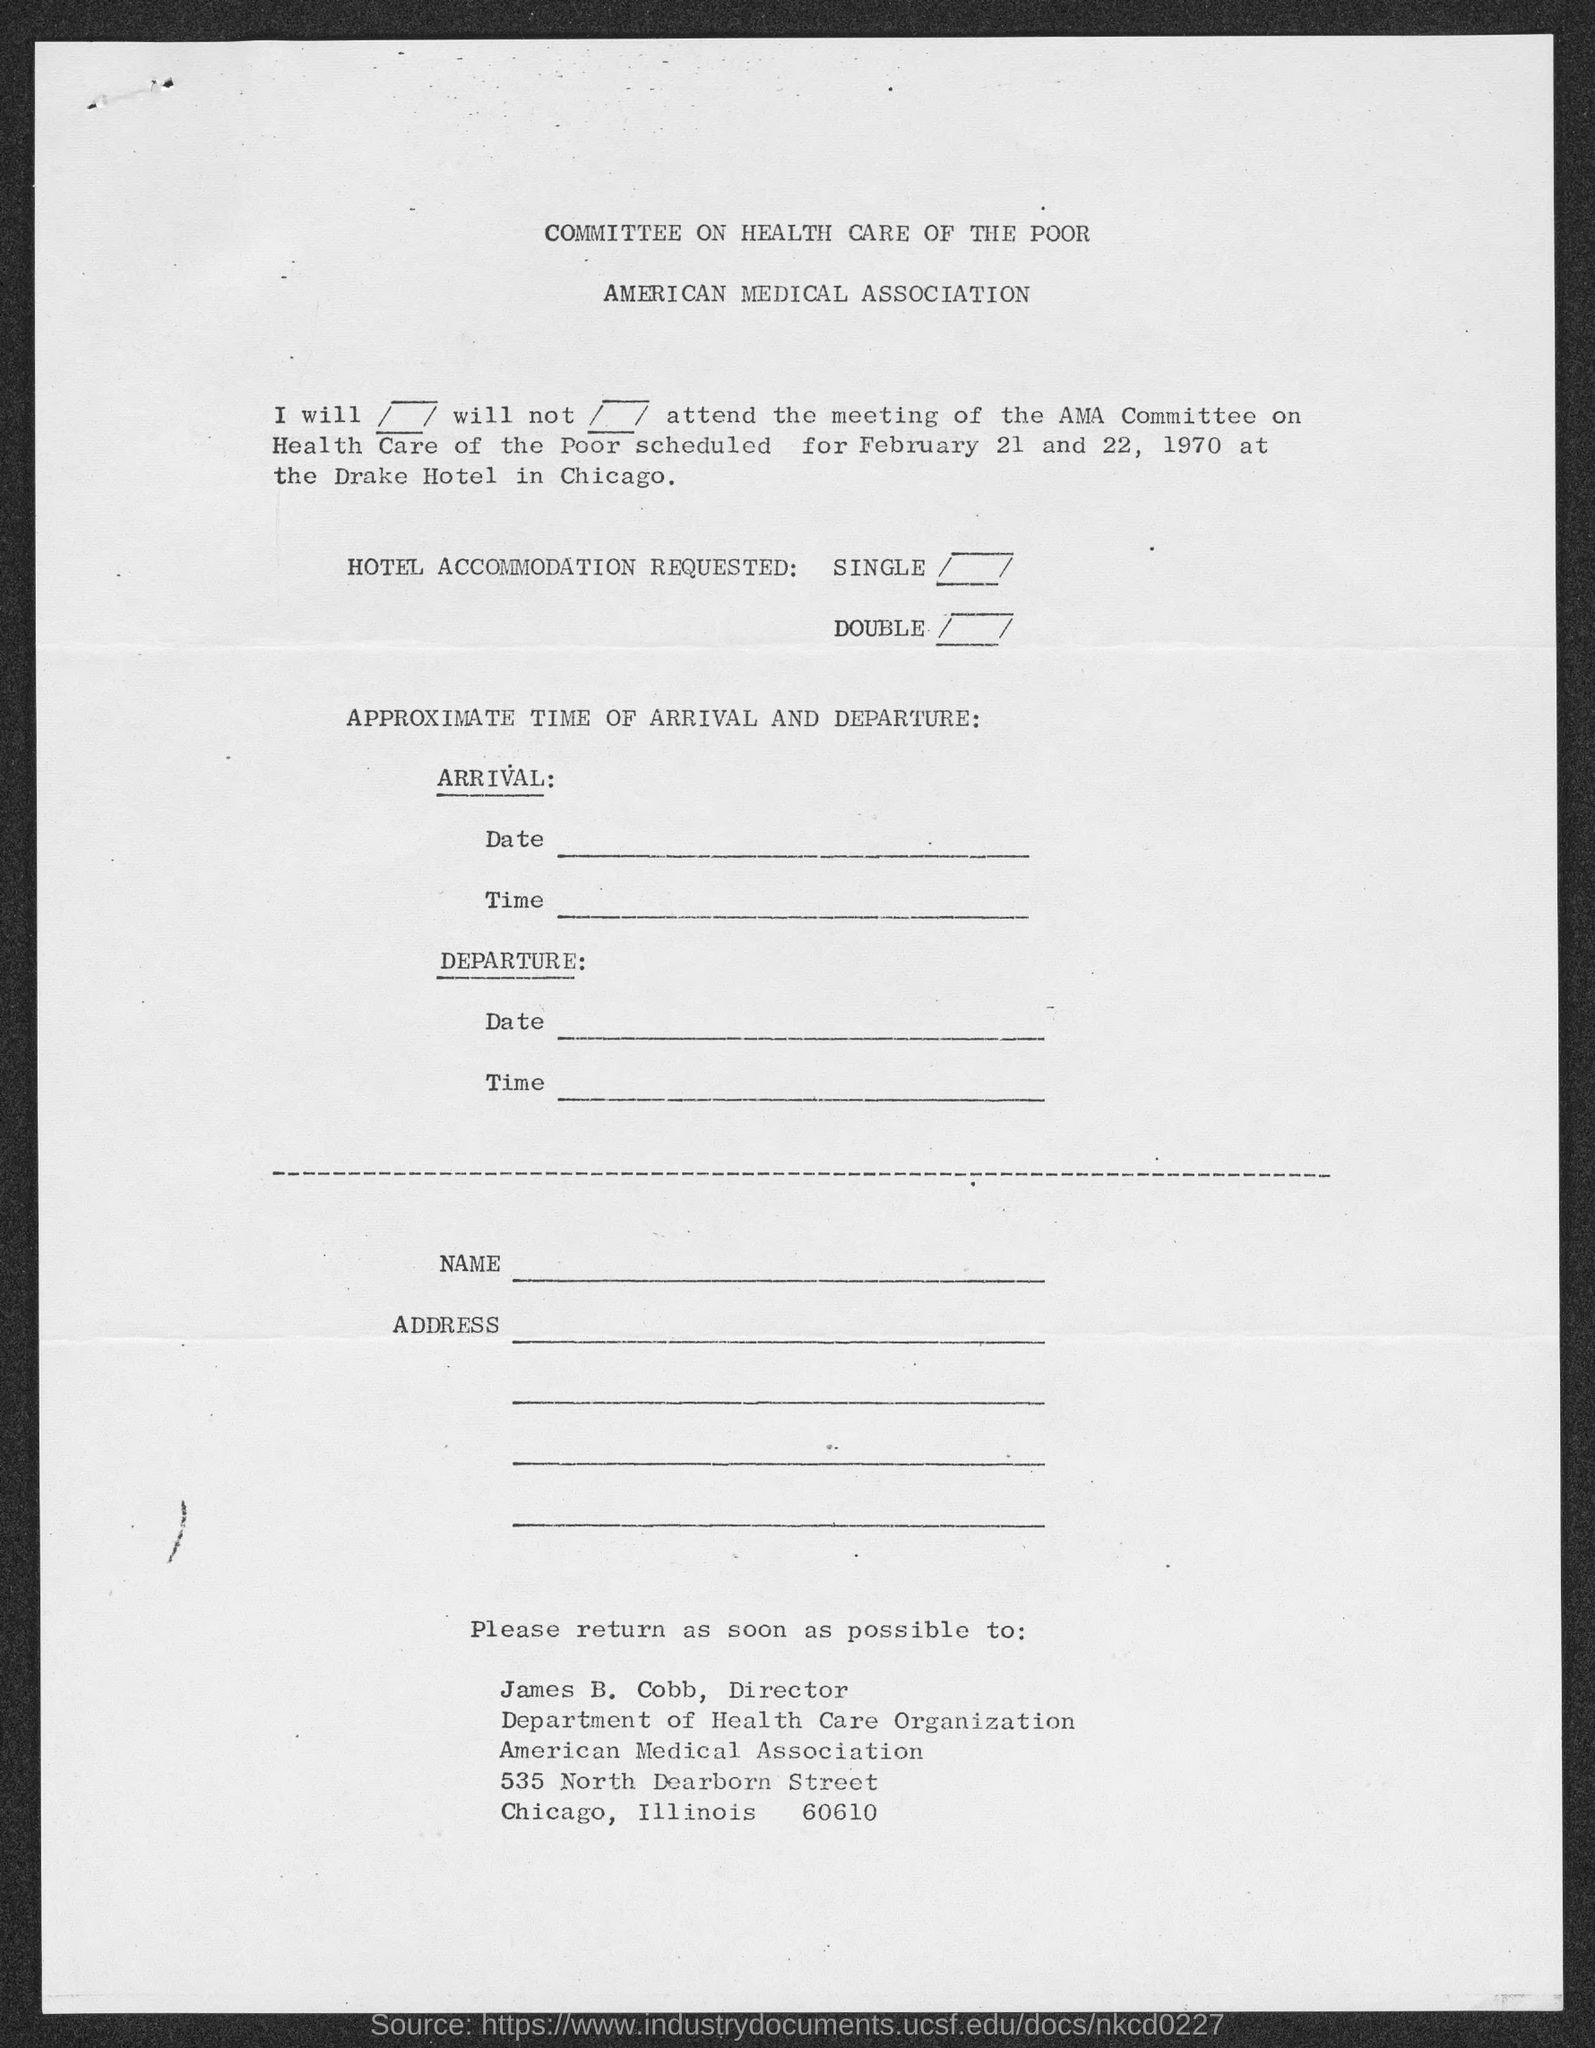Specify some key components in this picture. James B. Cobb holds the position of Director. The American Medical Association is located in Chicago. 